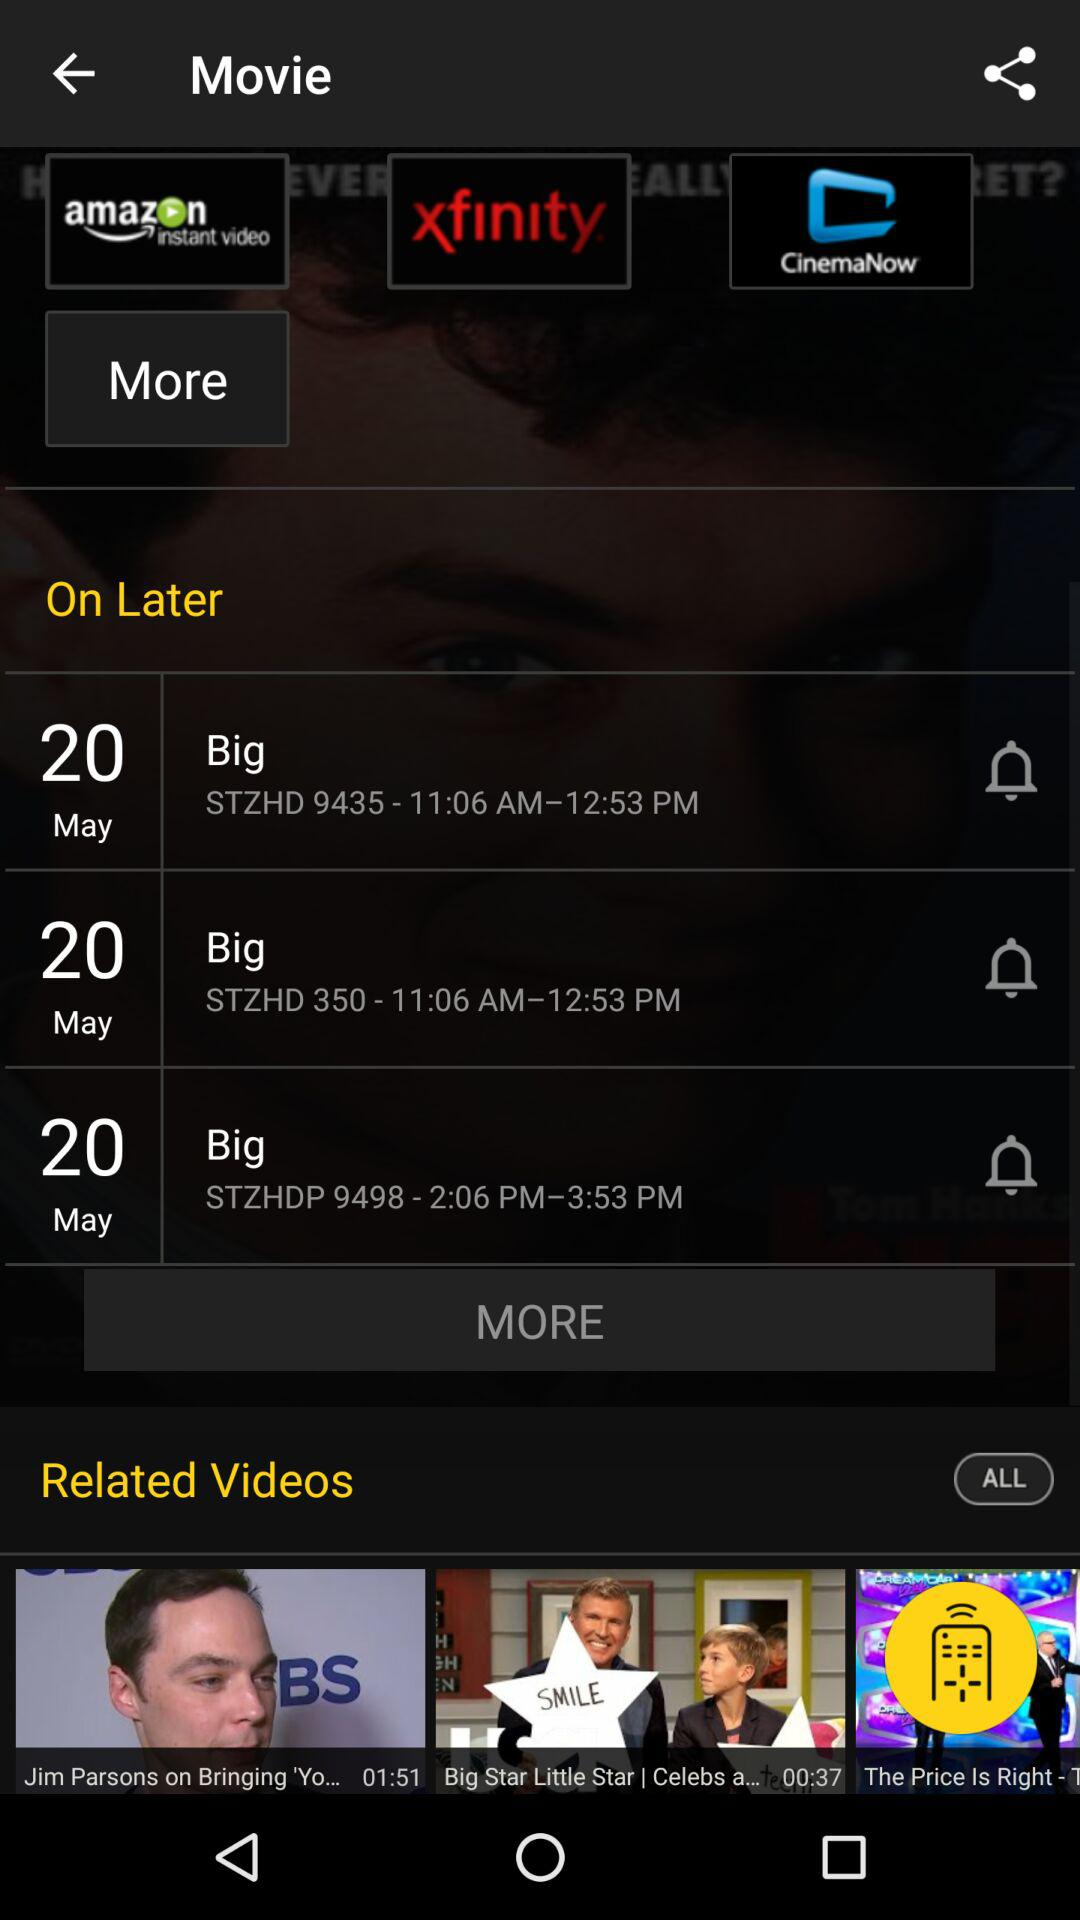What are the app names? The app names are "amazon", "Xfinity" and "CinemaNow". 